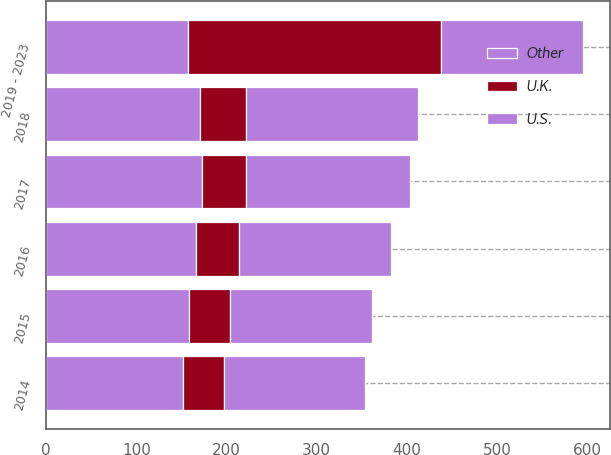Convert chart. <chart><loc_0><loc_0><loc_500><loc_500><stacked_bar_chart><ecel><fcel>2014<fcel>2015<fcel>2016<fcel>2017<fcel>2018<fcel>2019 - 2023<nl><fcel>U.S.<fcel>156<fcel>157<fcel>168<fcel>181<fcel>190<fcel>157.5<nl><fcel>Other<fcel>152<fcel>158<fcel>166<fcel>173<fcel>171<fcel>157.5<nl><fcel>U.K.<fcel>45<fcel>46<fcel>48<fcel>49<fcel>51<fcel>280<nl></chart> 